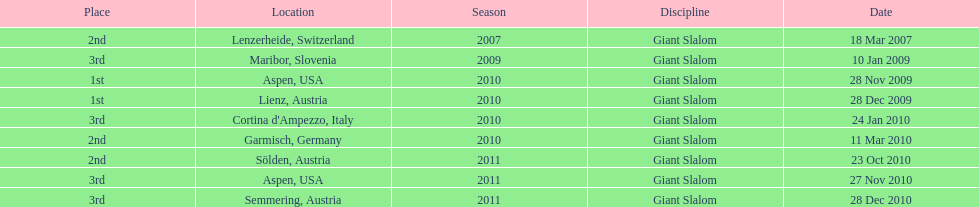What was the finishing place of the last race in december 2010? 3rd. 